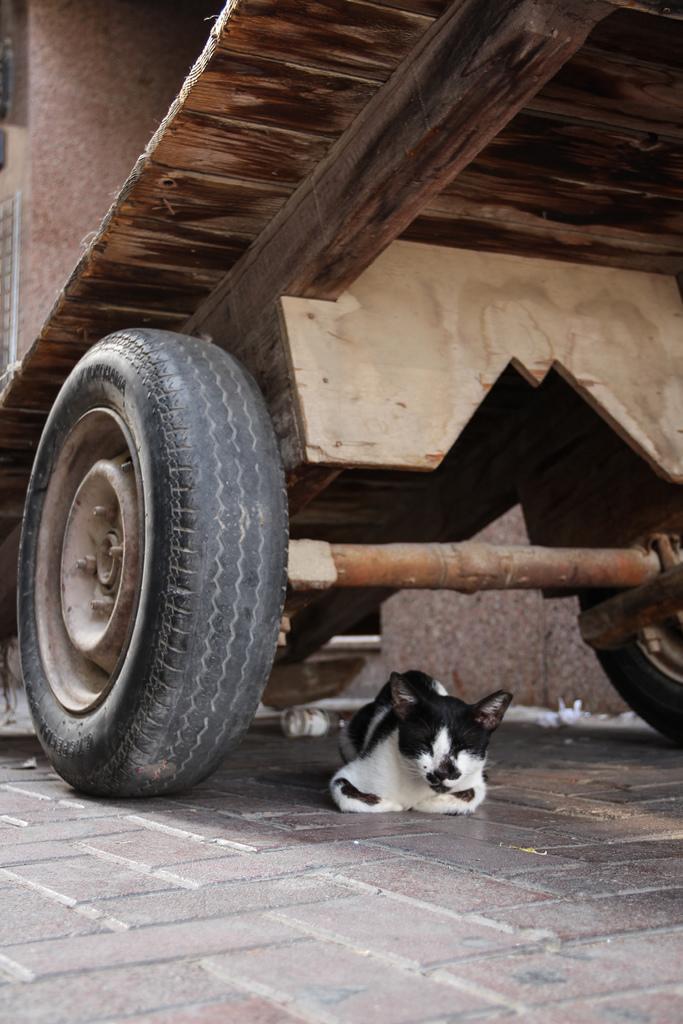Please provide a concise description of this image. In this image we can see a cat on the floor and there is a vehicle and we can see a wall in the background. 